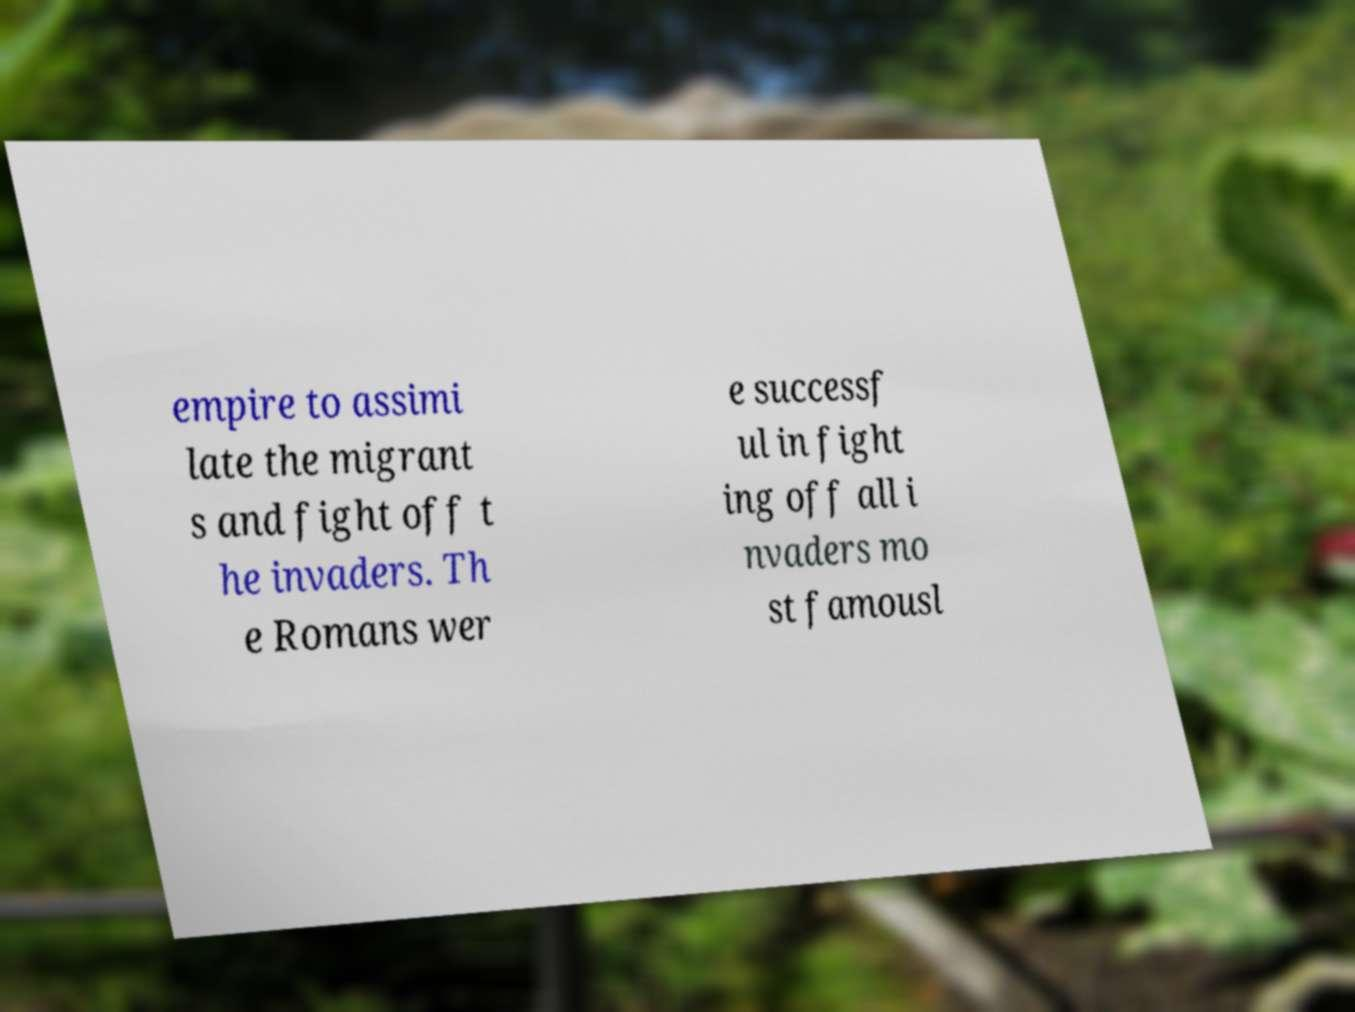Could you extract and type out the text from this image? empire to assimi late the migrant s and fight off t he invaders. Th e Romans wer e successf ul in fight ing off all i nvaders mo st famousl 